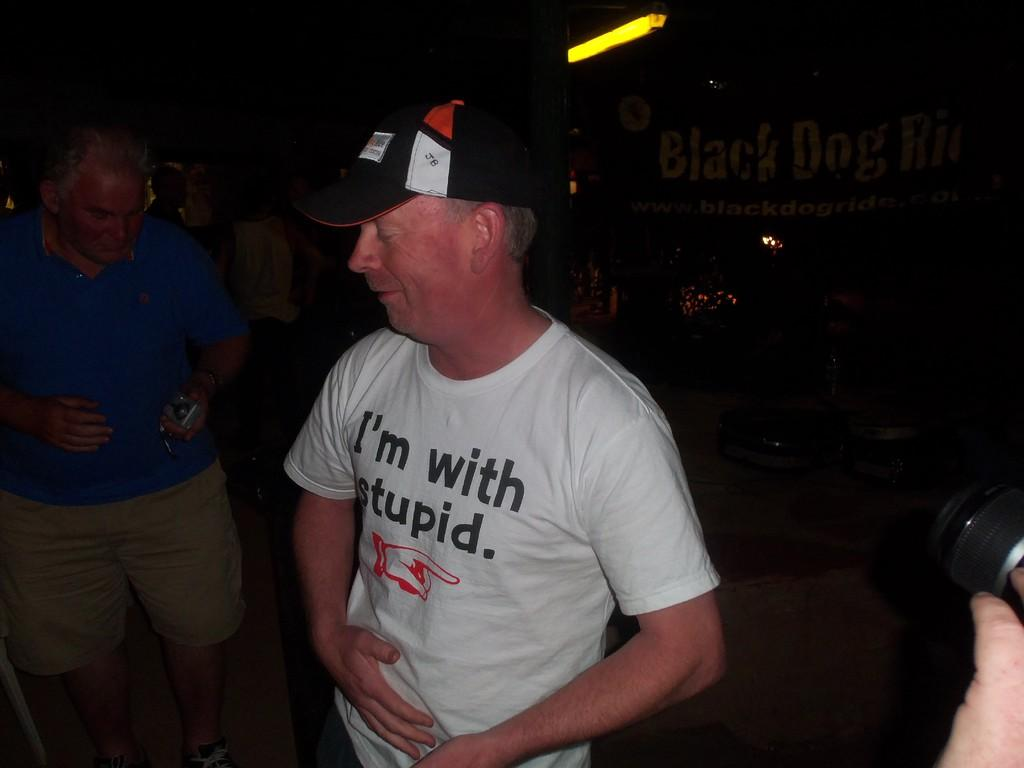How many people are in the image? There are two people in the image. What is the first person wearing? The first person is wearing a white color shirt and a black color cap. What is the second person wearing? The second person is wearing a blue shirt and brown pants. What is the color of the background in the image? The background of the image is black. What type of mine can be seen in the background of the image? There is no mine present in the image; the background is black. What game are the people playing in the image? There is no game being played in the image; the people are simply standing. 